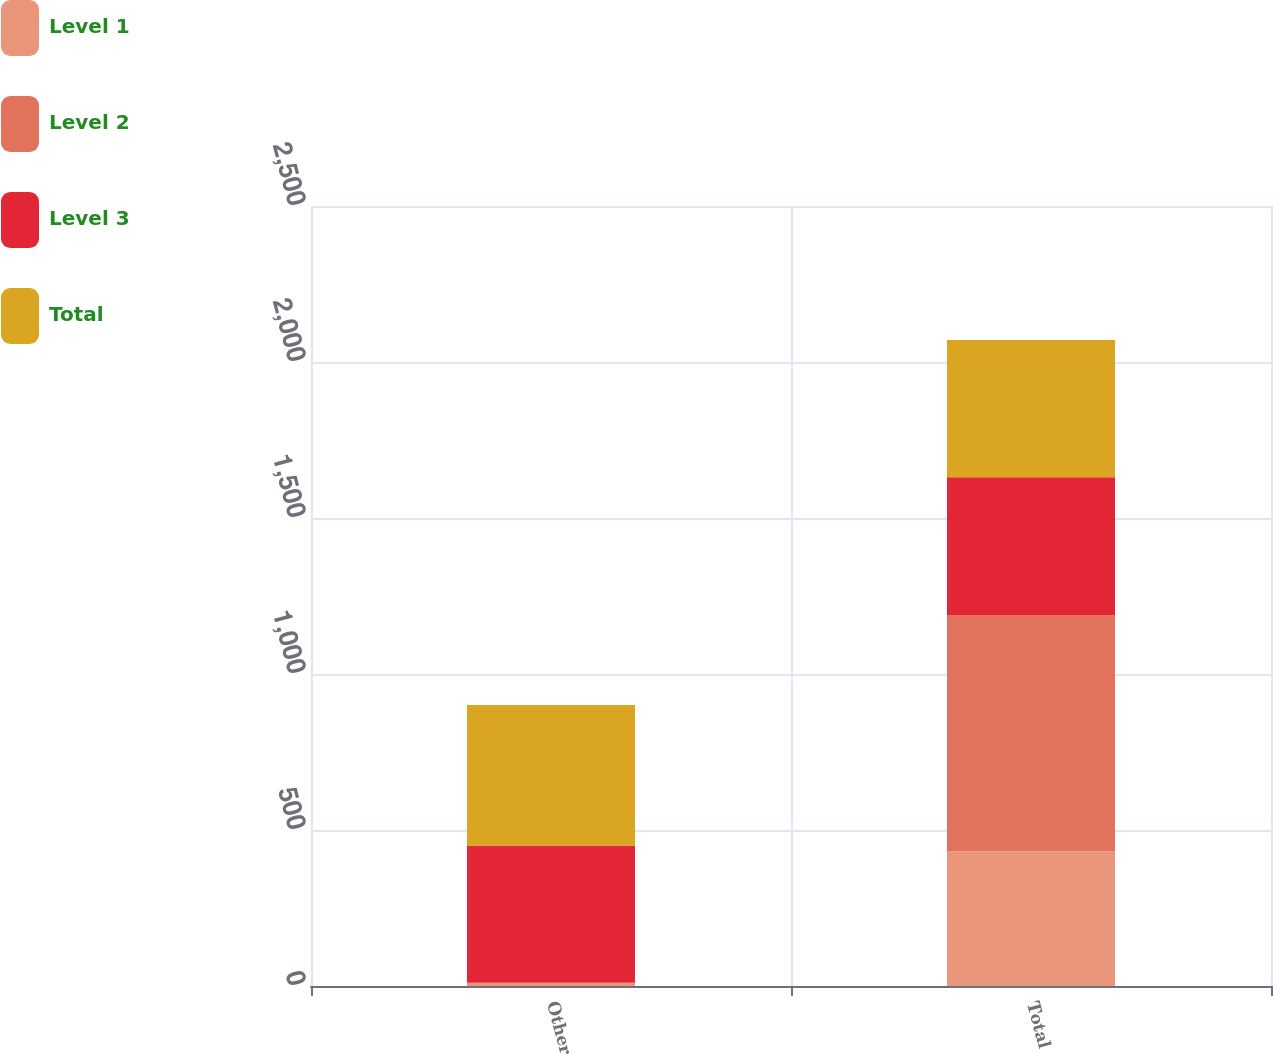<chart> <loc_0><loc_0><loc_500><loc_500><stacked_bar_chart><ecel><fcel>Other<fcel>Total<nl><fcel>Level 1<fcel>10.7<fcel>431.8<nl><fcel>Level 2<fcel>0.1<fcel>757.3<nl><fcel>Level 3<fcel>439.6<fcel>441.9<nl><fcel>Total<fcel>450.4<fcel>439.6<nl></chart> 